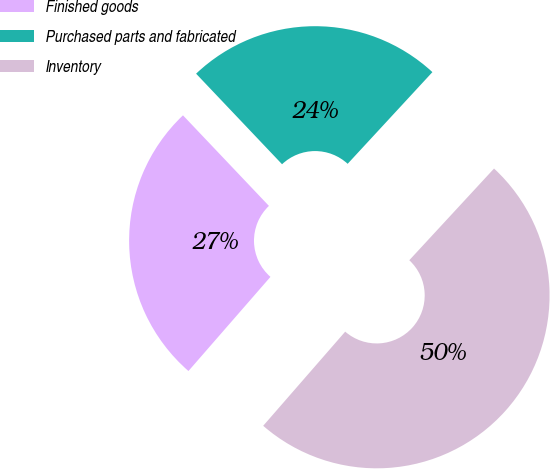Convert chart to OTSL. <chart><loc_0><loc_0><loc_500><loc_500><pie_chart><fcel>Finished goods<fcel>Purchased parts and fabricated<fcel>Inventory<nl><fcel>26.51%<fcel>23.96%<fcel>49.53%<nl></chart> 